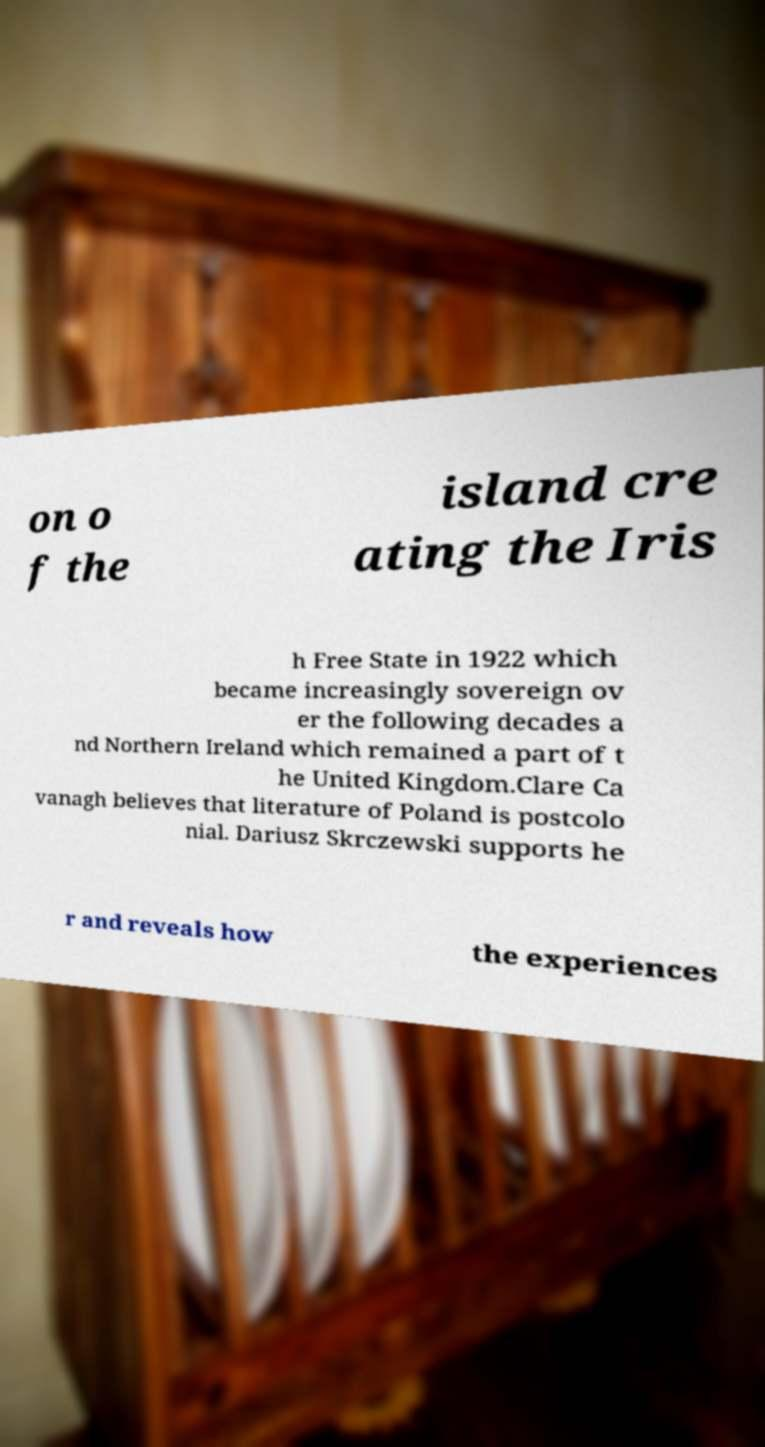There's text embedded in this image that I need extracted. Can you transcribe it verbatim? on o f the island cre ating the Iris h Free State in 1922 which became increasingly sovereign ov er the following decades a nd Northern Ireland which remained a part of t he United Kingdom.Clare Ca vanagh believes that literature of Poland is postcolo nial. Dariusz Skrczewski supports he r and reveals how the experiences 